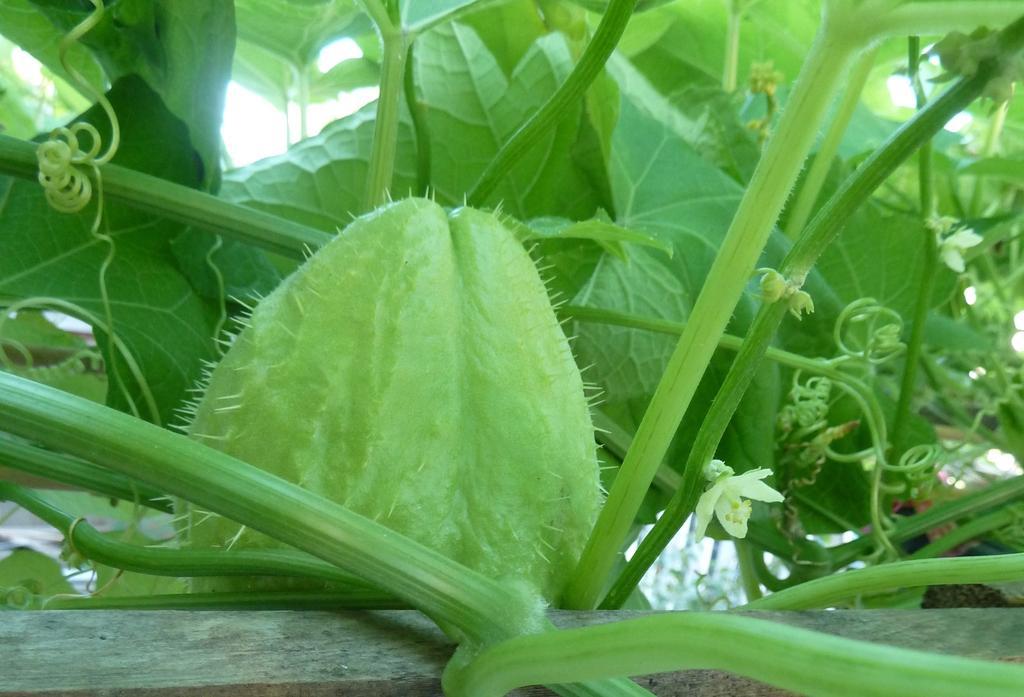Can you describe this image briefly? In this picture we can see a plant with a chayote and a flower. Behind the plants there is a sky. 